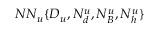<formula> <loc_0><loc_0><loc_500><loc_500>N N _ { u } \{ D _ { u } , N _ { d } ^ { u } , N _ { B } ^ { u } , N _ { h } ^ { u } \}</formula> 